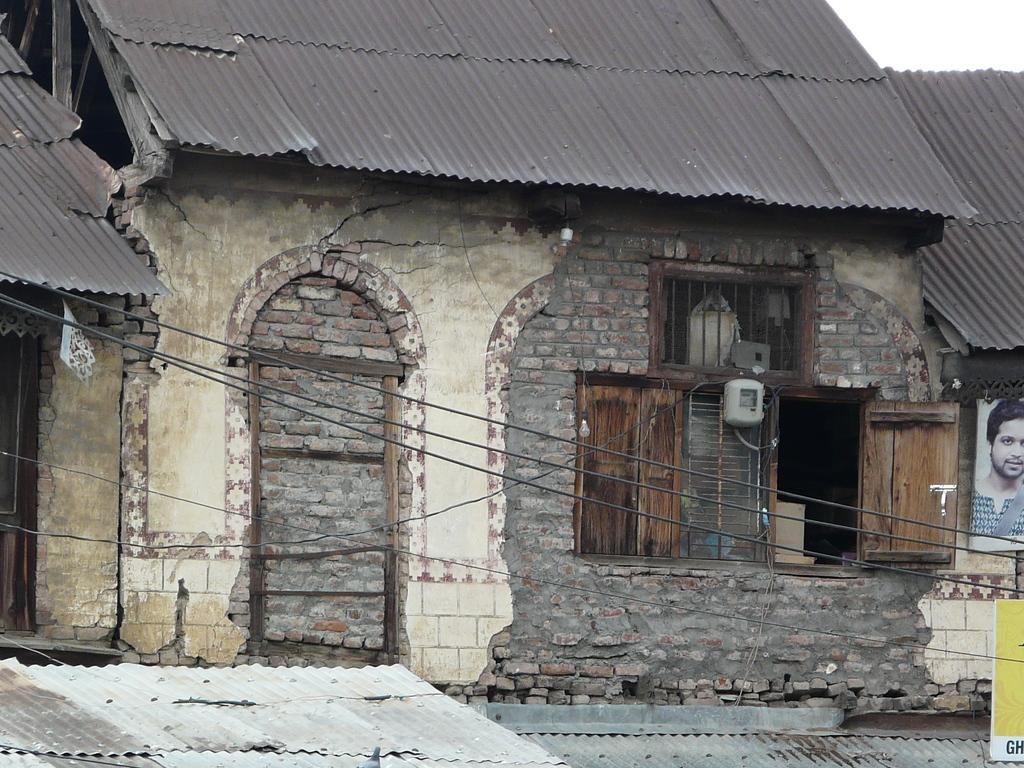What type of material is used for the walls of the houses in the image? The houses have brick walls in the image. What type of windows are on the houses? The houses have wooden windows. What can be seen on the right side of the image? There is a banner on the right side of the image. What type of locket is hanging from the banner in the image? There is no locket present in the image; it features houses with brick walls and wooden windows, along with a banner on the right side. How does the frog grip the banner in the image? There is no frog present in the image; it only features houses with brick walls and wooden windows, along with a banner on the right side. 